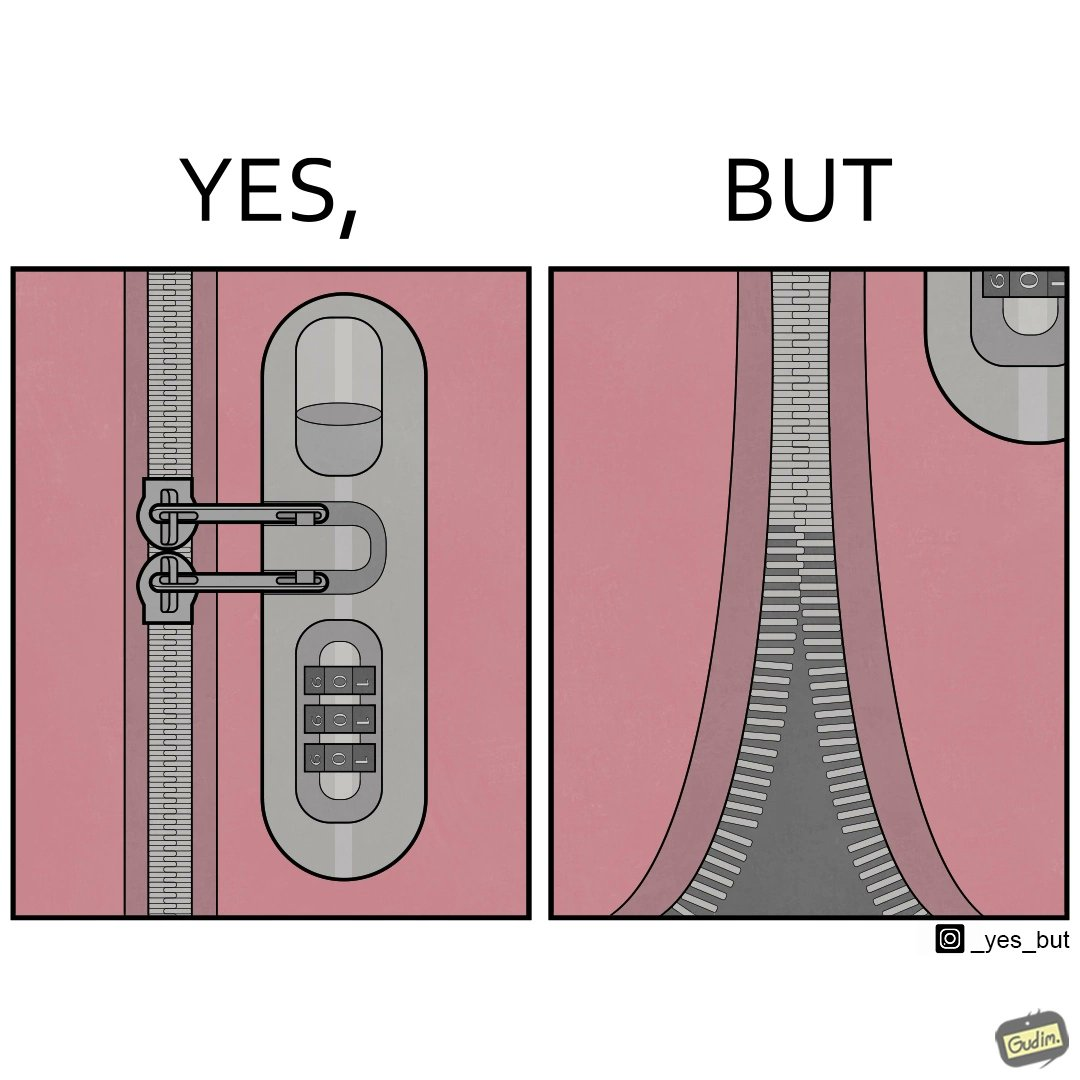Describe what you see in this image. The images are funny since it shows how even though we use padlocks to keep our luggage safe on trolleys, it is rendered useless as the zip chain breaks anyways 